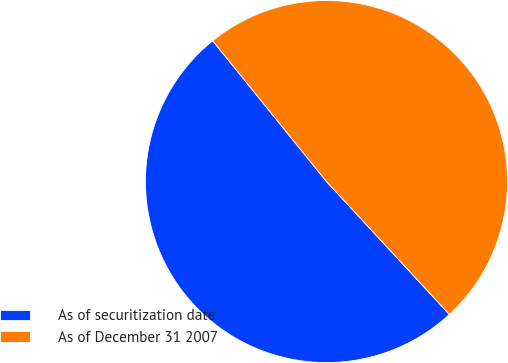Convert chart to OTSL. <chart><loc_0><loc_0><loc_500><loc_500><pie_chart><fcel>As of securitization date<fcel>As of December 31 2007<nl><fcel>51.06%<fcel>48.94%<nl></chart> 